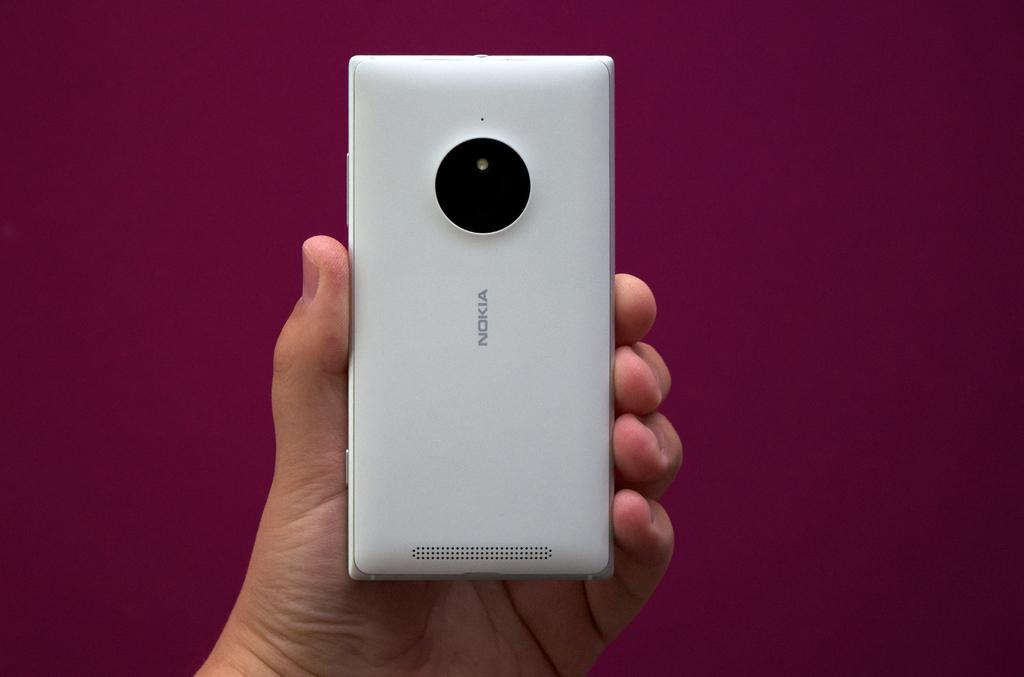<image>
Share a concise interpretation of the image provided. A white Nokia phone is showing the camera while being held by someone's left hand 